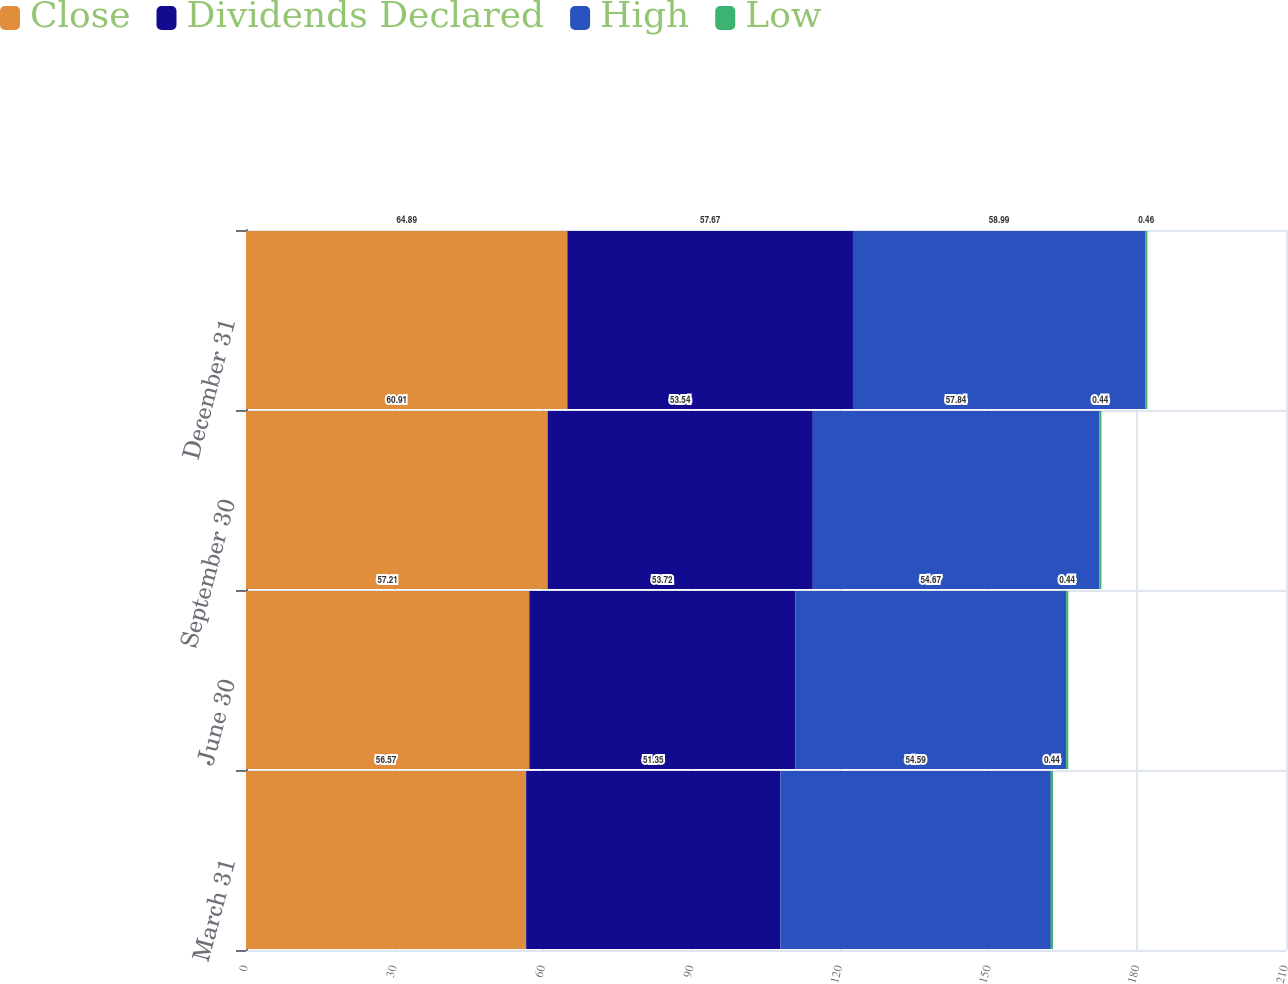Convert chart to OTSL. <chart><loc_0><loc_0><loc_500><loc_500><stacked_bar_chart><ecel><fcel>March 31<fcel>June 30<fcel>September 30<fcel>December 31<nl><fcel>Close<fcel>56.57<fcel>57.21<fcel>60.91<fcel>64.89<nl><fcel>Dividends Declared<fcel>51.35<fcel>53.72<fcel>53.54<fcel>57.67<nl><fcel>High<fcel>54.59<fcel>54.67<fcel>57.84<fcel>58.99<nl><fcel>Low<fcel>0.44<fcel>0.44<fcel>0.44<fcel>0.46<nl></chart> 